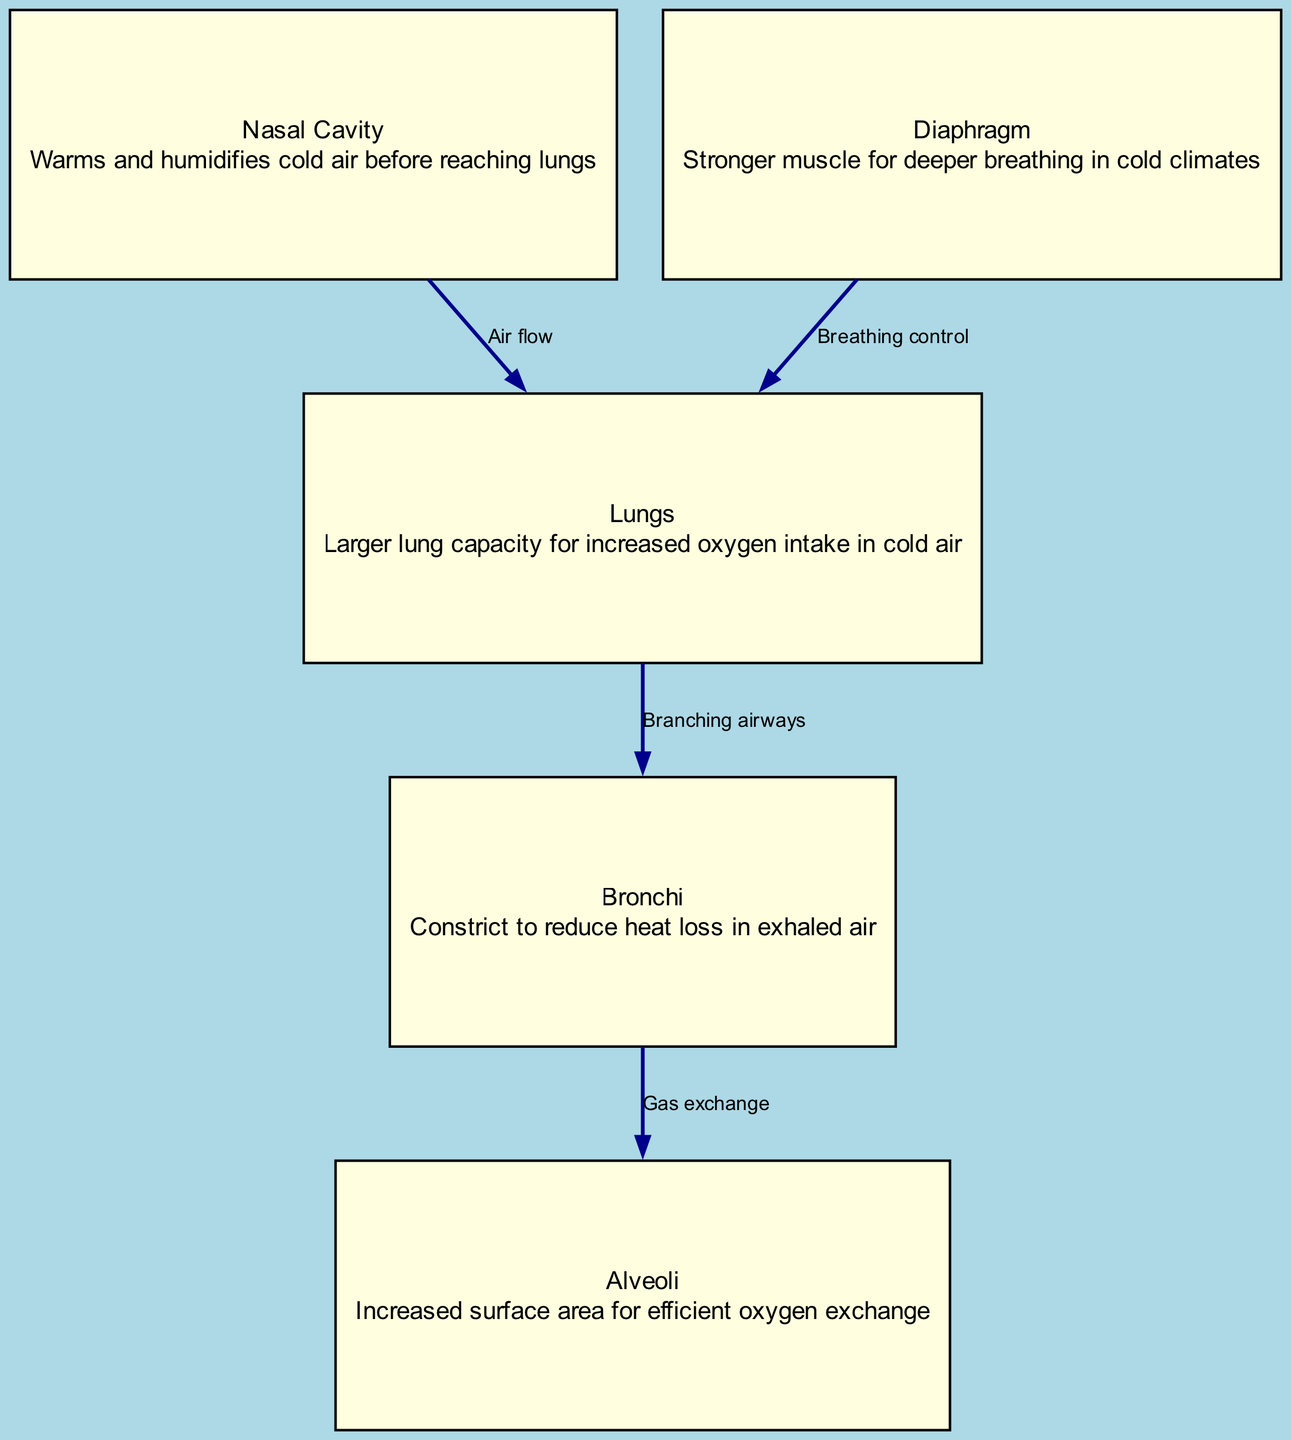What is the function of the nasal cavity? The nasal cavity's primary function is to warm and humidify cold air before it reaches the lungs. This is indicated in the diagram under the nasal cavity node description.
Answer: Warms and humidifies How many nodes are present in the diagram? By counting the nodes listed (lungs, nasal cavity, bronchi, alveoli, diaphragm), there are a total of five distinct nodes represented in the diagram.
Answer: Five What do the bronchi do in relation to air? According to the diagram, bronchi constrict to reduce heat loss in exhaled air, indicating their role in managing temperature during respiration.
Answer: Constrict Which node has an increased surface area for oxygen exchange? The diagram specifies that the alveoli have an increased surface area for efficient oxygen exchange, as stated in their description.
Answer: Alveoli What describes the connection from the diaphragm to the lungs? The connection from the diaphragm to the lungs is labeled as "Breathing control," which highlights the diaphragm's role in managing inhalation and exhalation processes.
Answer: Breathing control What is the role of the diaphragm in cold climates? The diaphragm is described in the diagram as a stronger muscle for deeper breathing in cold climates, reflecting its importance in adapting to such conditions.
Answer: Stronger muscle What process occurs between the bronchi and alveoli? The diagram illustrates that the process occurring between bronchi and alveoli is gas exchange, as indicated in the labeled edge connecting these two nodes.
Answer: Gas exchange Which part of the respiratory system has a larger capacity? According to the diagram, the lungs have a larger lung capacity for increased oxygen intake in colder air, as mentioned in the lungs description.
Answer: Lungs 